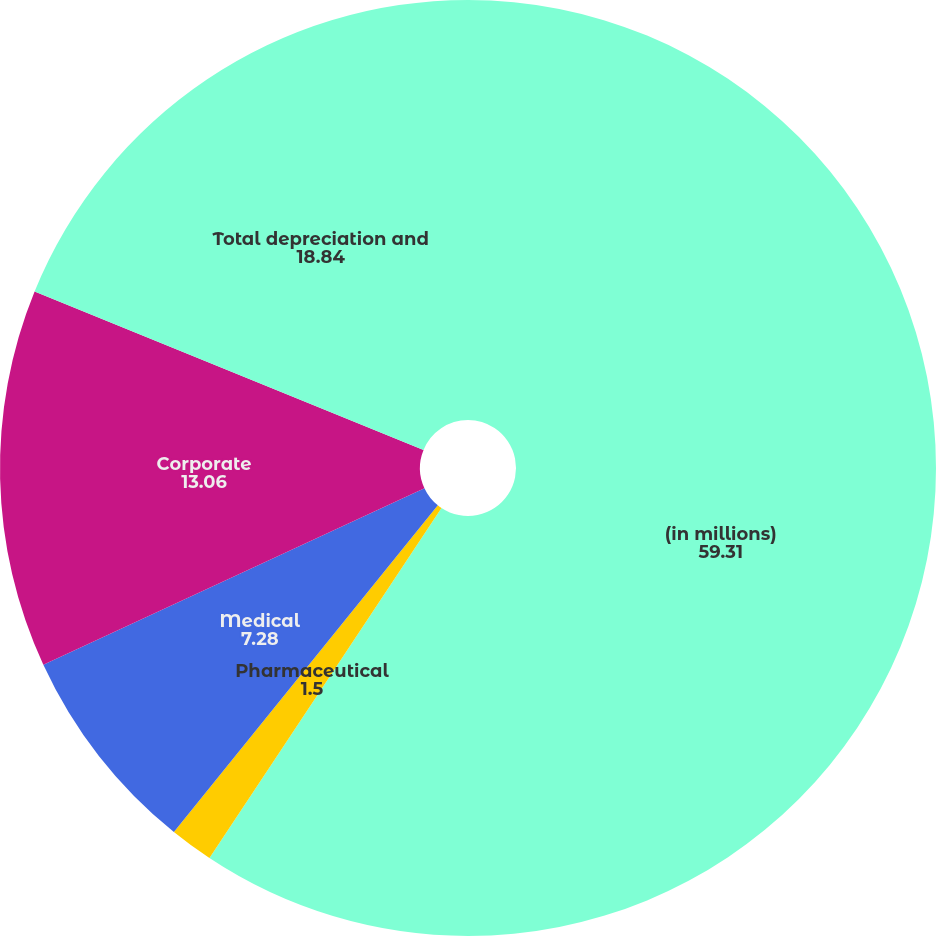<chart> <loc_0><loc_0><loc_500><loc_500><pie_chart><fcel>(in millions)<fcel>Pharmaceutical<fcel>Medical<fcel>Corporate<fcel>Total depreciation and<nl><fcel>59.31%<fcel>1.5%<fcel>7.28%<fcel>13.06%<fcel>18.84%<nl></chart> 